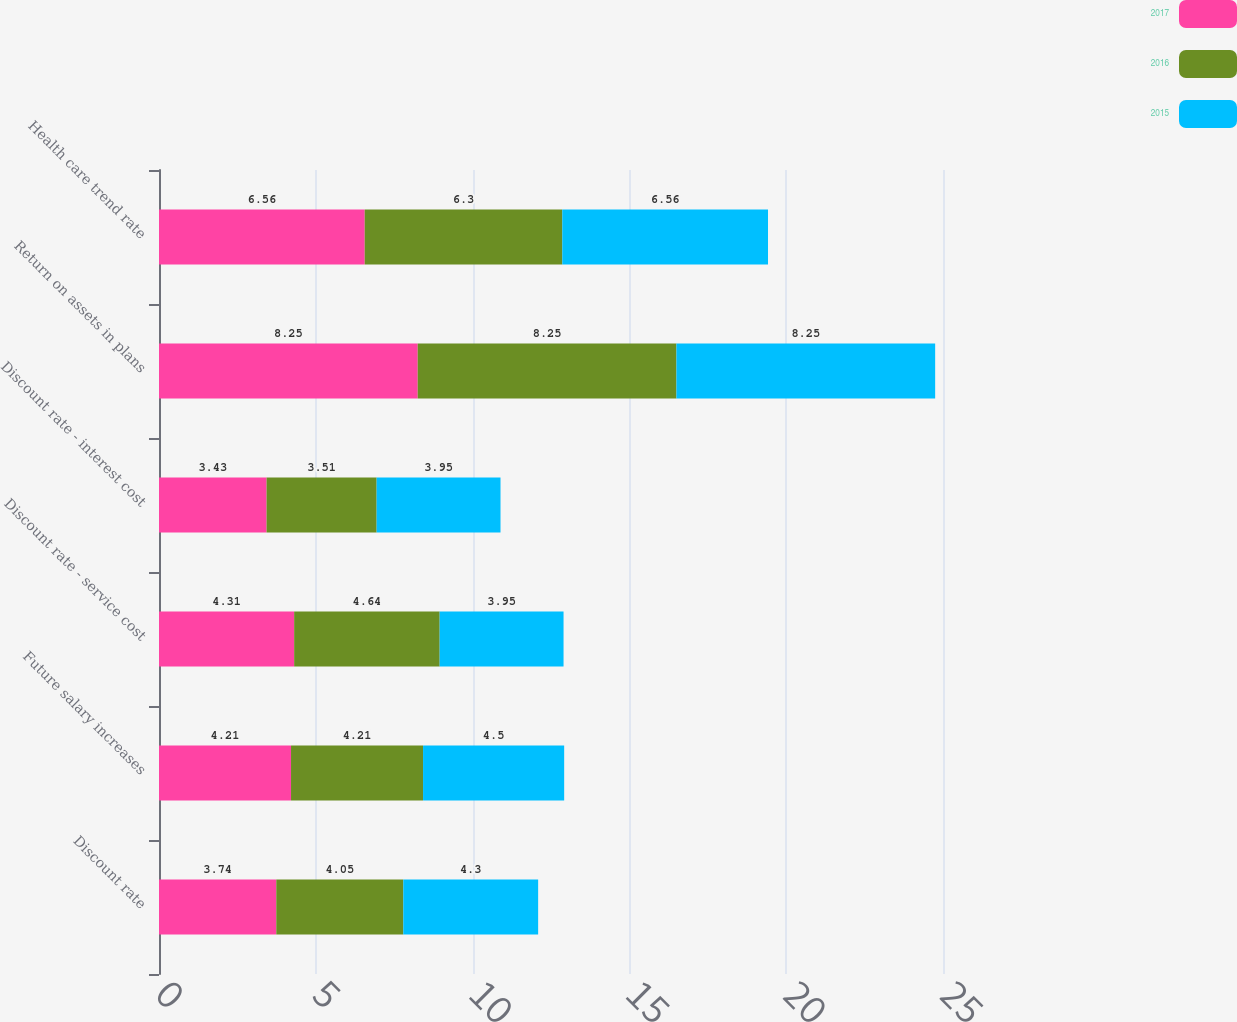Convert chart. <chart><loc_0><loc_0><loc_500><loc_500><stacked_bar_chart><ecel><fcel>Discount rate<fcel>Future salary increases<fcel>Discount rate - service cost<fcel>Discount rate - interest cost<fcel>Return on assets in plans<fcel>Health care trend rate<nl><fcel>2017<fcel>3.74<fcel>4.21<fcel>4.31<fcel>3.43<fcel>8.25<fcel>6.56<nl><fcel>2016<fcel>4.05<fcel>4.21<fcel>4.64<fcel>3.51<fcel>8.25<fcel>6.3<nl><fcel>2015<fcel>4.3<fcel>4.5<fcel>3.95<fcel>3.95<fcel>8.25<fcel>6.56<nl></chart> 